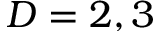Convert formula to latex. <formula><loc_0><loc_0><loc_500><loc_500>D = 2 , 3</formula> 